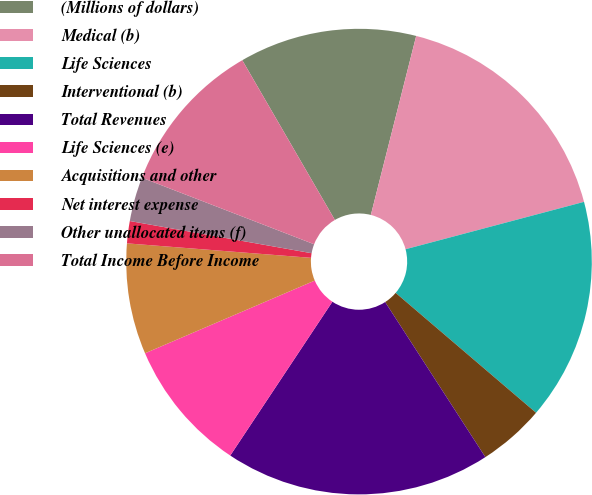<chart> <loc_0><loc_0><loc_500><loc_500><pie_chart><fcel>(Millions of dollars)<fcel>Medical (b)<fcel>Life Sciences<fcel>Interventional (b)<fcel>Total Revenues<fcel>Life Sciences (e)<fcel>Acquisitions and other<fcel>Net interest expense<fcel>Other unallocated items (f)<fcel>Total Income Before Income<nl><fcel>12.31%<fcel>16.92%<fcel>15.38%<fcel>4.62%<fcel>18.46%<fcel>9.23%<fcel>7.69%<fcel>1.54%<fcel>3.08%<fcel>10.77%<nl></chart> 